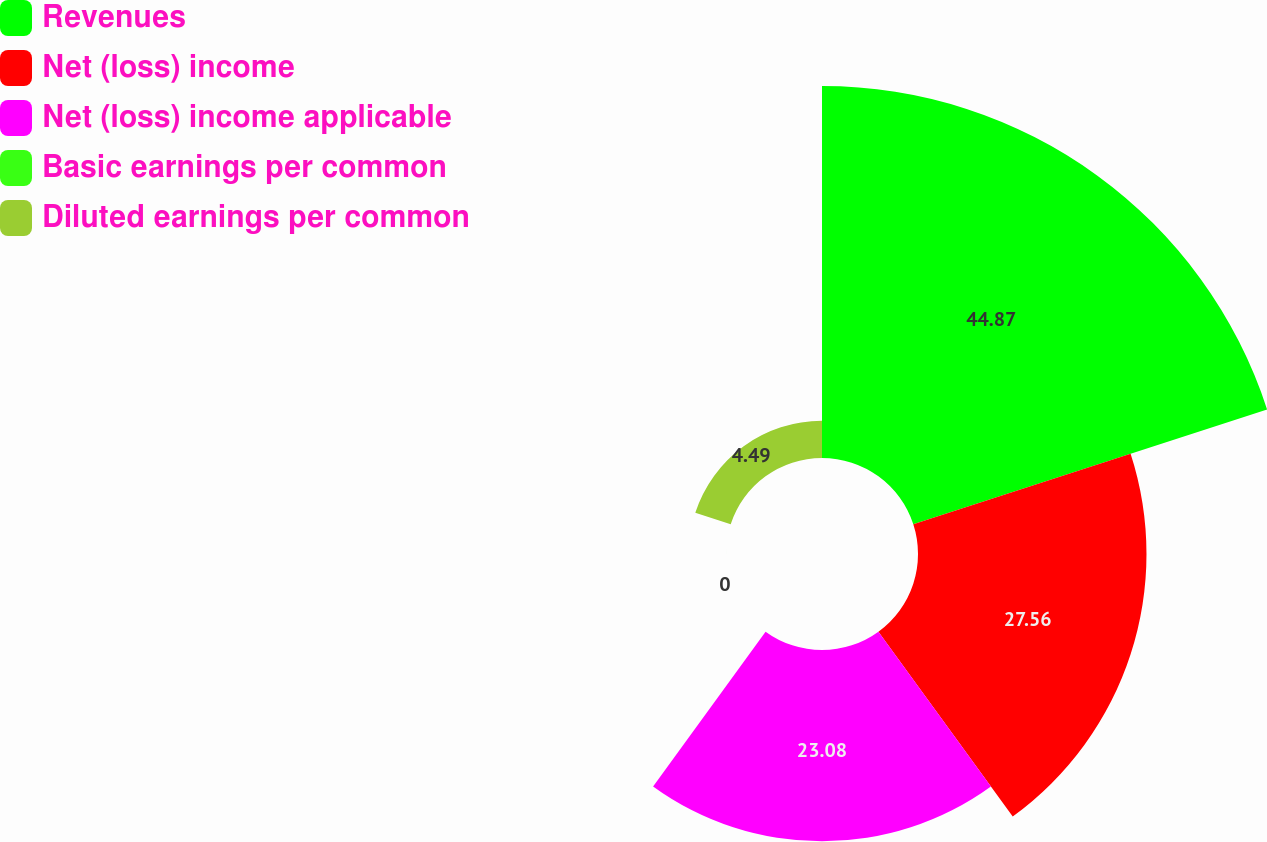Convert chart. <chart><loc_0><loc_0><loc_500><loc_500><pie_chart><fcel>Revenues<fcel>Net (loss) income<fcel>Net (loss) income applicable<fcel>Basic earnings per common<fcel>Diluted earnings per common<nl><fcel>44.87%<fcel>27.56%<fcel>23.08%<fcel>0.0%<fcel>4.49%<nl></chart> 